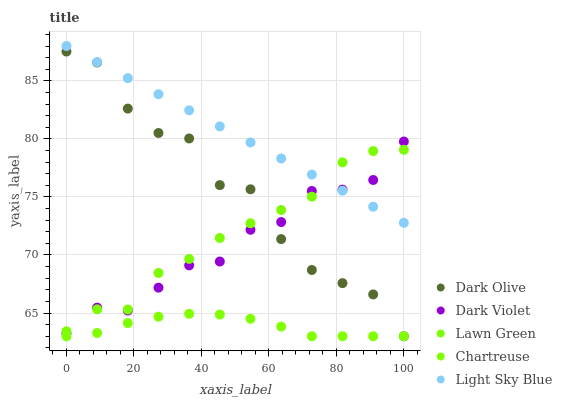Does Chartreuse have the minimum area under the curve?
Answer yes or no. Yes. Does Light Sky Blue have the maximum area under the curve?
Answer yes or no. Yes. Does Dark Olive have the minimum area under the curve?
Answer yes or no. No. Does Dark Olive have the maximum area under the curve?
Answer yes or no. No. Is Light Sky Blue the smoothest?
Answer yes or no. Yes. Is Dark Olive the roughest?
Answer yes or no. Yes. Is Chartreuse the smoothest?
Answer yes or no. No. Is Chartreuse the roughest?
Answer yes or no. No. Does Chartreuse have the lowest value?
Answer yes or no. Yes. Does Dark Violet have the lowest value?
Answer yes or no. No. Does Light Sky Blue have the highest value?
Answer yes or no. Yes. Does Dark Olive have the highest value?
Answer yes or no. No. Is Chartreuse less than Lawn Green?
Answer yes or no. Yes. Is Dark Violet greater than Chartreuse?
Answer yes or no. Yes. Does Chartreuse intersect Dark Olive?
Answer yes or no. Yes. Is Chartreuse less than Dark Olive?
Answer yes or no. No. Is Chartreuse greater than Dark Olive?
Answer yes or no. No. Does Chartreuse intersect Lawn Green?
Answer yes or no. No. 